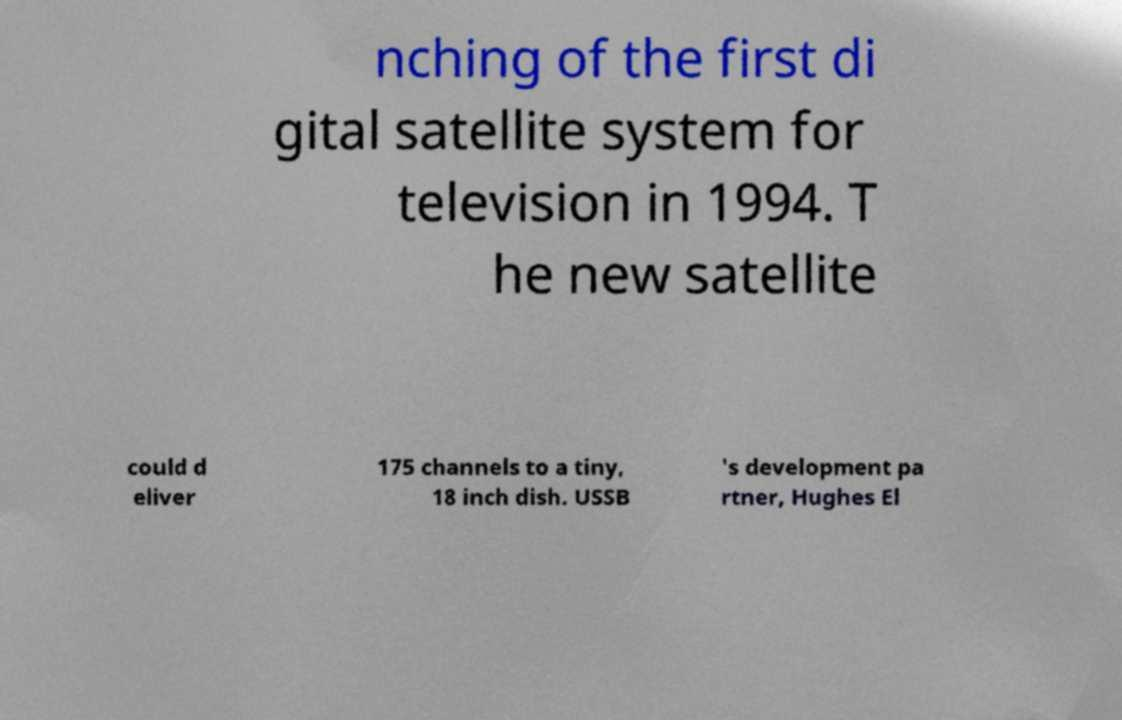Could you assist in decoding the text presented in this image and type it out clearly? nching of the first di gital satellite system for television in 1994. T he new satellite could d eliver 175 channels to a tiny, 18 inch dish. USSB 's development pa rtner, Hughes El 